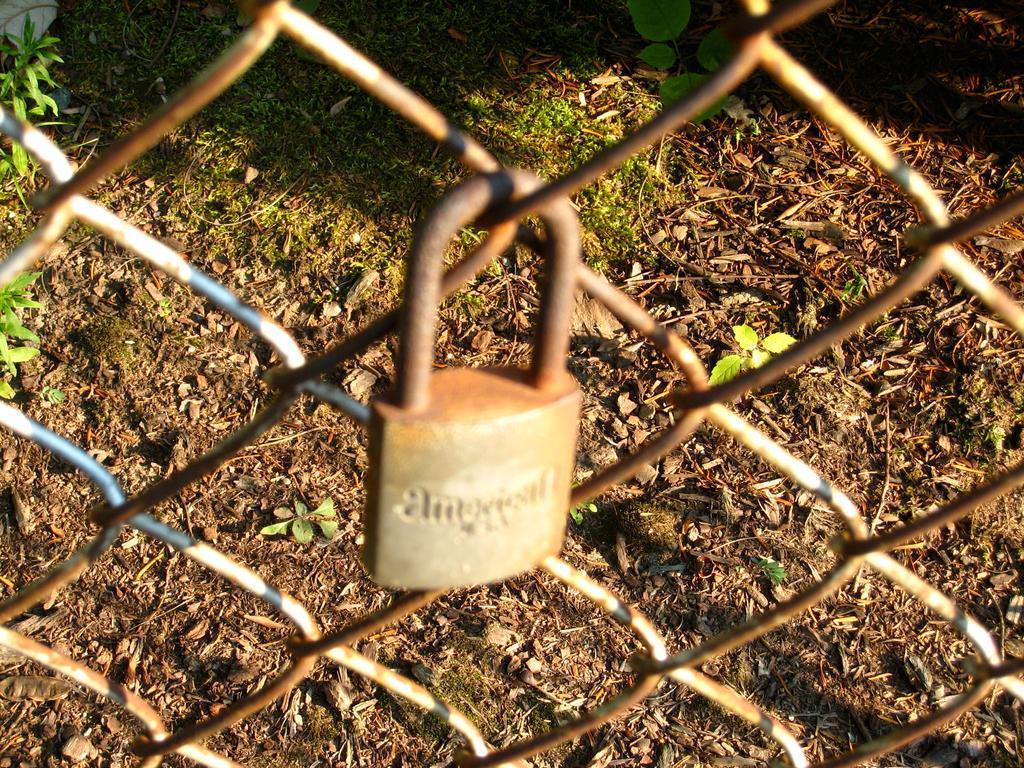Can you describe this image briefly? In this image in the front there is a lock on the grill. In the background there is grass and there are leaves. 